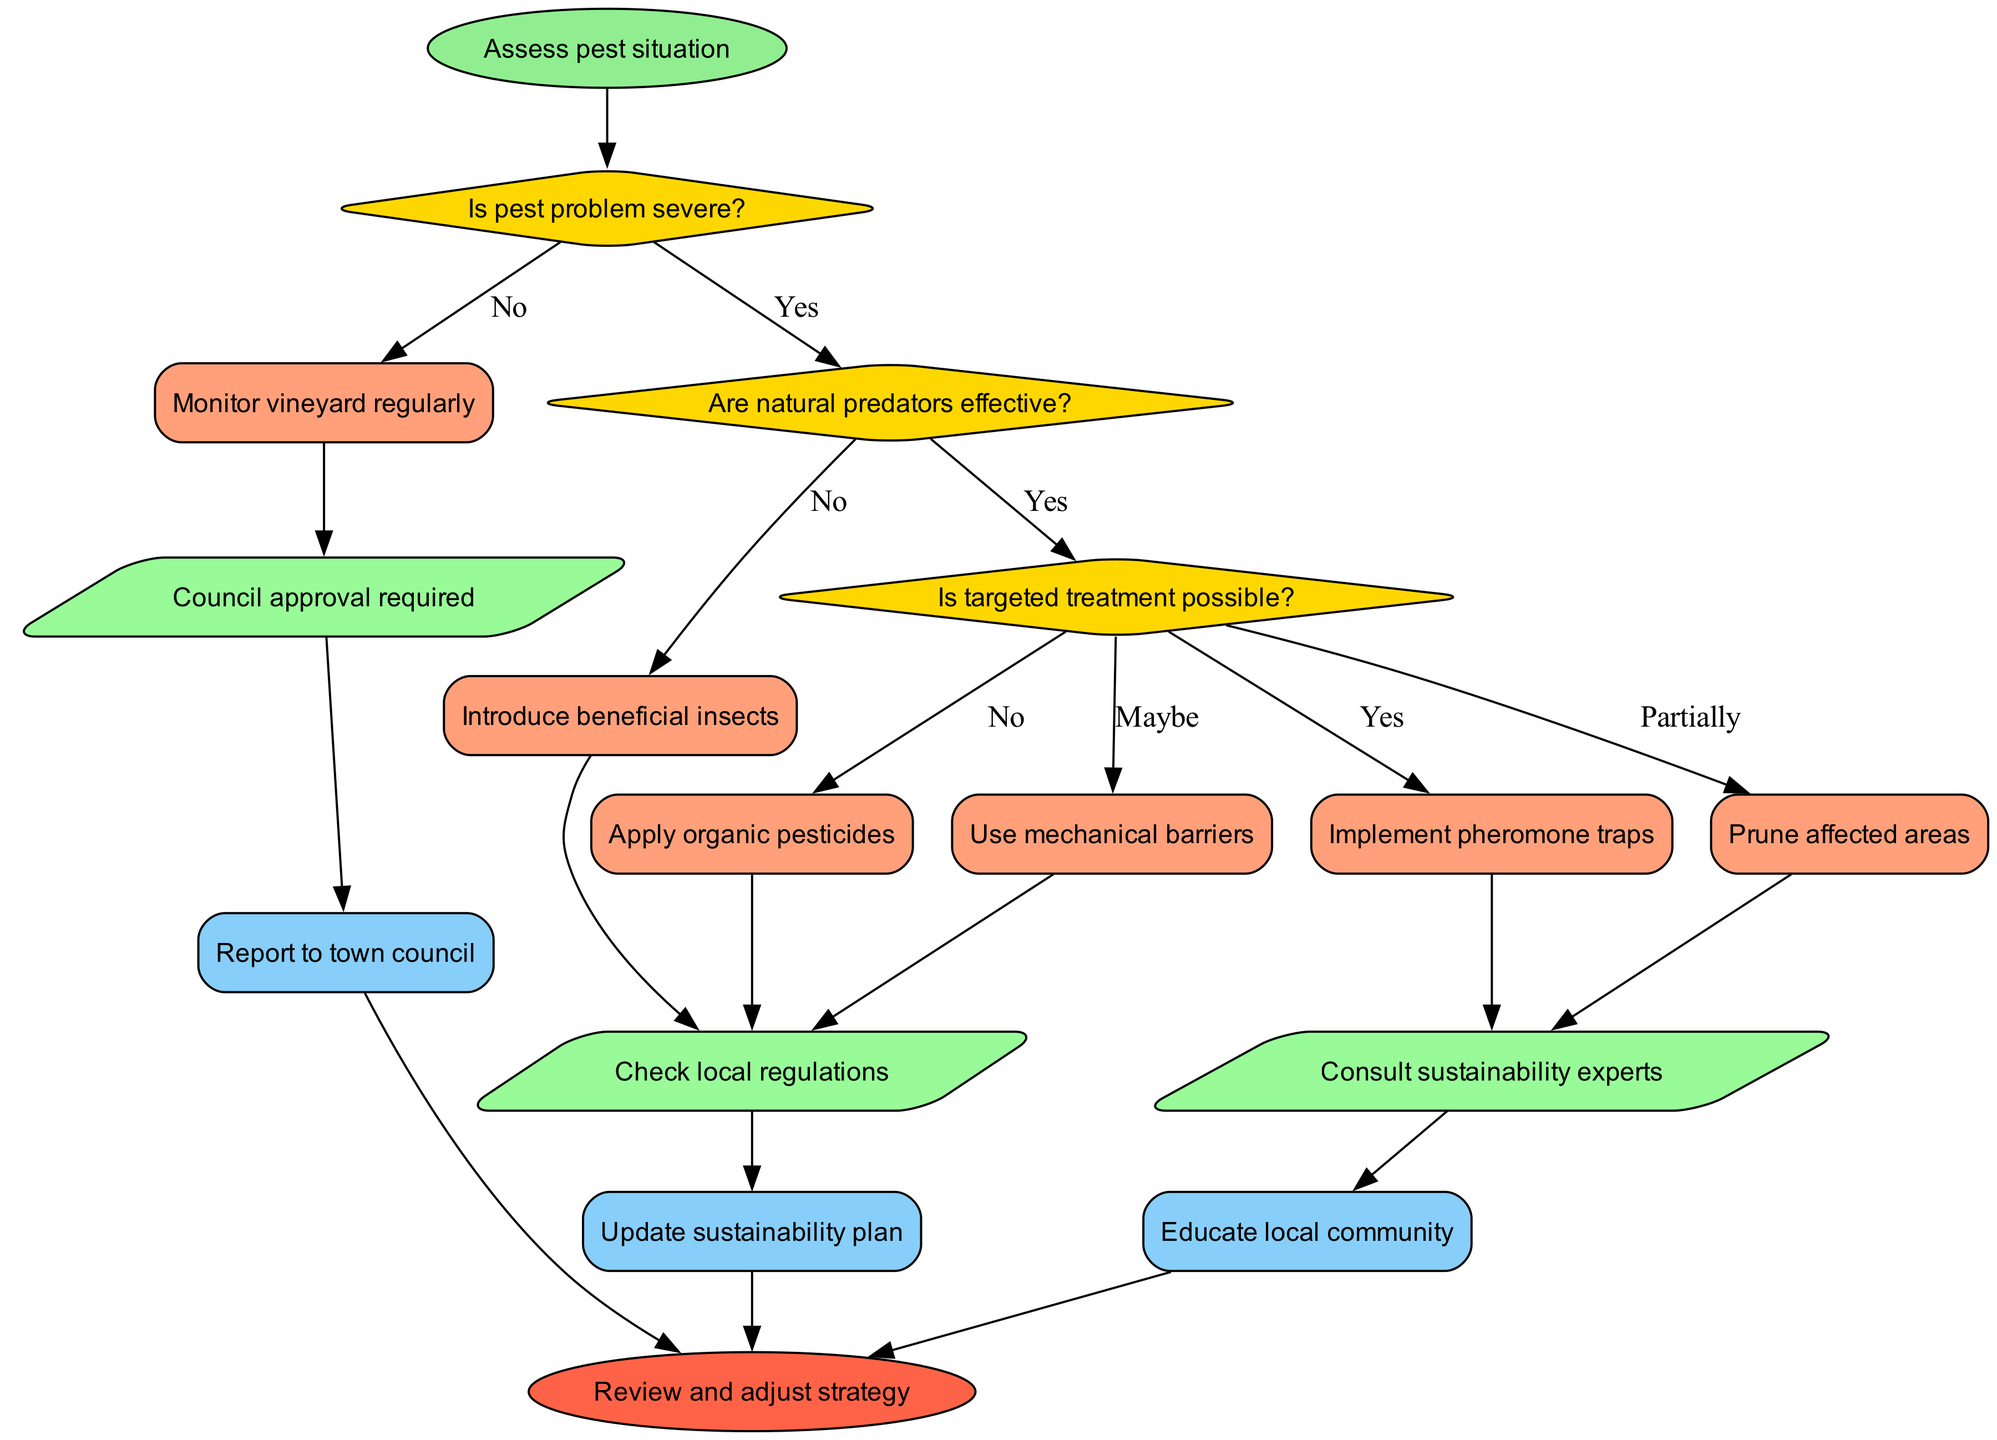What is the start point of the process? The start point is defined as the initial action or event in the flow chart, which in this case is "Assess pest situation."
Answer: Assess pest situation How many decision points are present in the diagram? By counting the listed decision points in the diagram, we identify three distinct decision points: "Is pest problem severe?", "Are natural predators effective?", and "Is targeted treatment possible?"
Answer: 3 What action follows the decision of "Is pest problem severe?" if the answer is yes? According to the flow, if the answer to "Is pest problem severe?" is yes, the next action taken is "Are natural predators effective?"
Answer: Are natural predators effective? If natural predators are not effective, what action is suggested next? If it is determined that the natural predators are not effective, the flow chart indicates that the next action to take is "Apply organic pesticides."
Answer: Apply organic pesticides What is the condition for the action "Introduce beneficial insects"? The condition preceding the action "Introduce beneficial insects" is "Check local regulations," indicating that regulations must be verified before introducing beneficial insects.
Answer: Check local regulations What are the three outcomes of this process? The outcomes of the flowchart reflect the final steps after consulting conditions, which are: "Report to town council," "Update sustainability plan," and "Educate local community."
Answer: Report to town council, Update sustainability plan, Educate local community If a vineyard chooses to use mechanical barriers, what condition do they need to check? The use of mechanical barriers is connected to the condition specified as "Consult sustainability experts," meaning that this consultation is required prior to proceeding with this action.
Answer: Consult sustainability experts How many actions can occur after assessing the pest situation? From the diagram, the initial assessment leads to two potential actions: introducing beneficial insects or monitoring the vineyard regularly if the pest problem is not severe, thus there are a total of five distinct actions overall after assessment.
Answer: 5 What is the relationship between the outcomes and the end point of the process? The outcomes lead into the end point, which is "Review and adjust strategy," indicating that after reporting outcomes, the final action of reviewing and adjusting is taken before concluding the pest control process.
Answer: Review and adjust strategy 